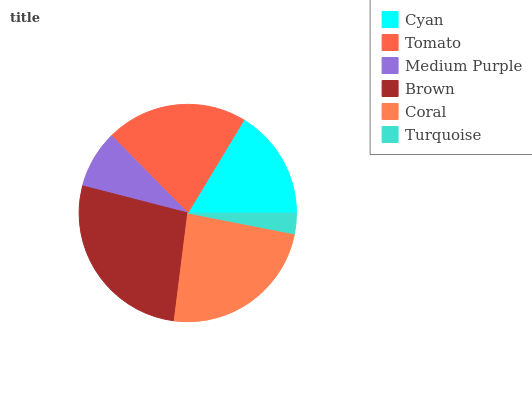Is Turquoise the minimum?
Answer yes or no. Yes. Is Brown the maximum?
Answer yes or no. Yes. Is Tomato the minimum?
Answer yes or no. No. Is Tomato the maximum?
Answer yes or no. No. Is Tomato greater than Cyan?
Answer yes or no. Yes. Is Cyan less than Tomato?
Answer yes or no. Yes. Is Cyan greater than Tomato?
Answer yes or no. No. Is Tomato less than Cyan?
Answer yes or no. No. Is Tomato the high median?
Answer yes or no. Yes. Is Cyan the low median?
Answer yes or no. Yes. Is Cyan the high median?
Answer yes or no. No. Is Turquoise the low median?
Answer yes or no. No. 